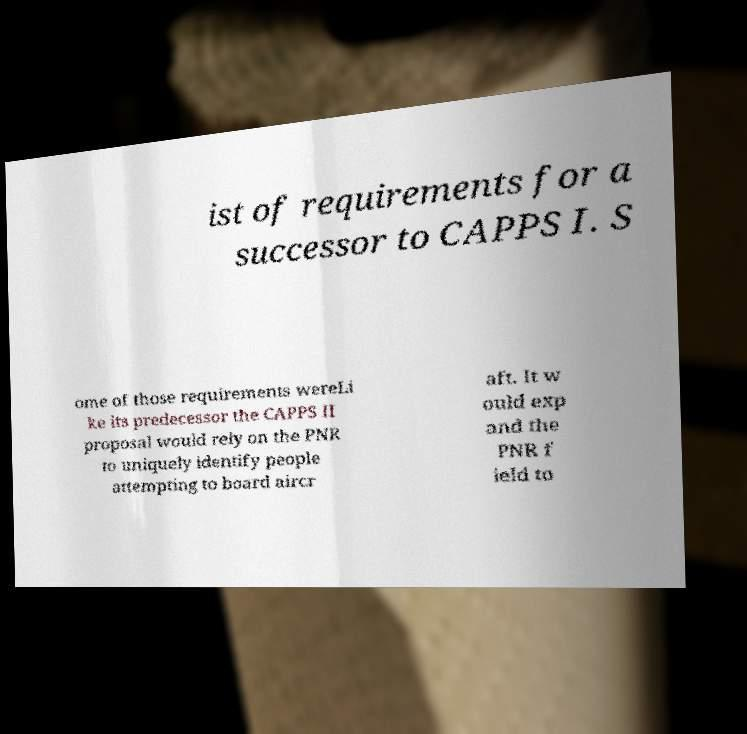Can you read and provide the text displayed in the image?This photo seems to have some interesting text. Can you extract and type it out for me? ist of requirements for a successor to CAPPS I. S ome of those requirements wereLi ke its predecessor the CAPPS II proposal would rely on the PNR to uniquely identify people attempting to board aircr aft. It w ould exp and the PNR f ield to 